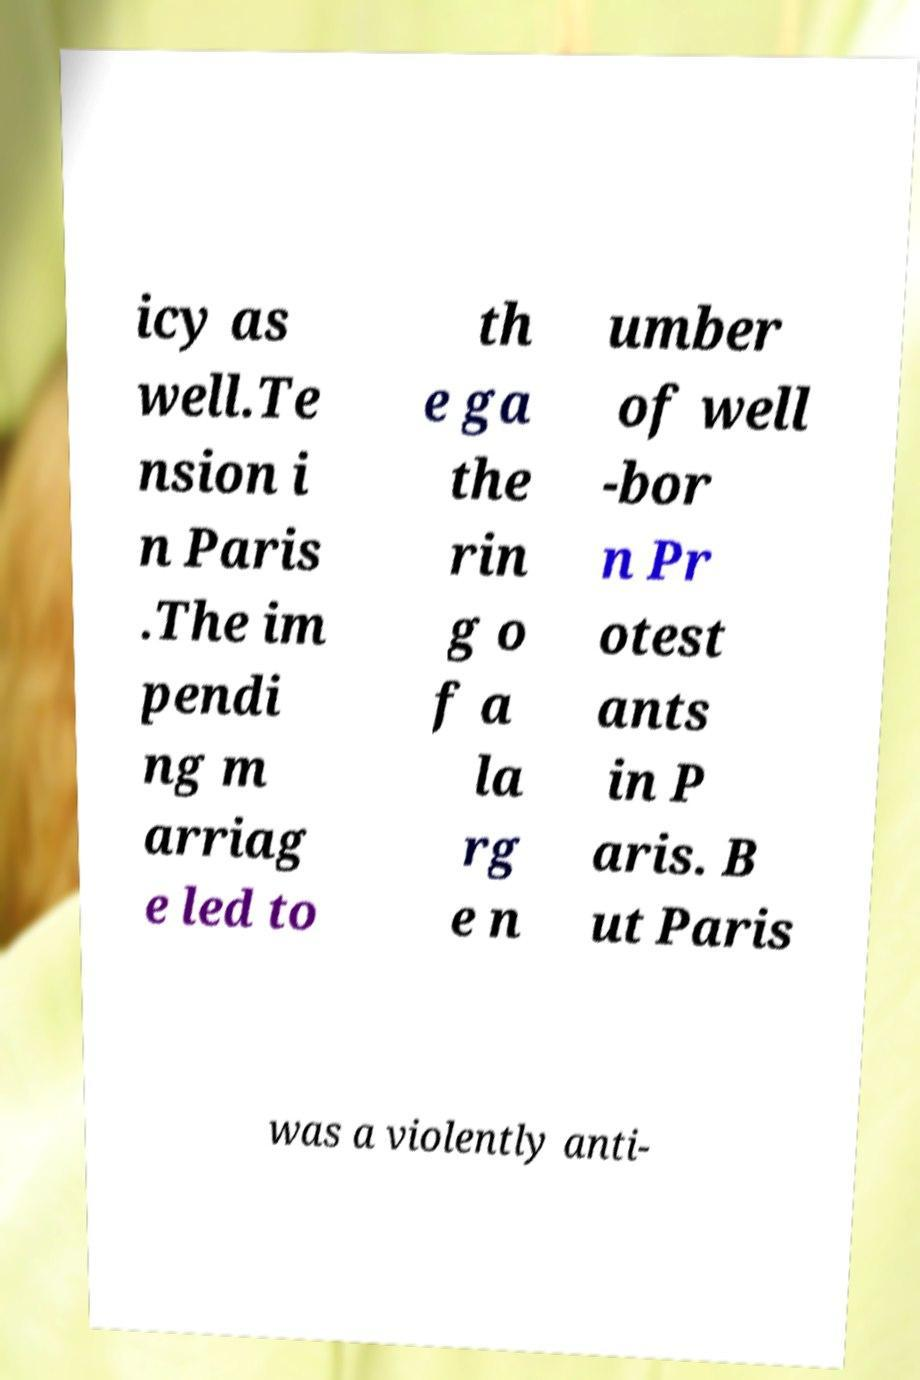Please read and relay the text visible in this image. What does it say? icy as well.Te nsion i n Paris .The im pendi ng m arriag e led to th e ga the rin g o f a la rg e n umber of well -bor n Pr otest ants in P aris. B ut Paris was a violently anti- 